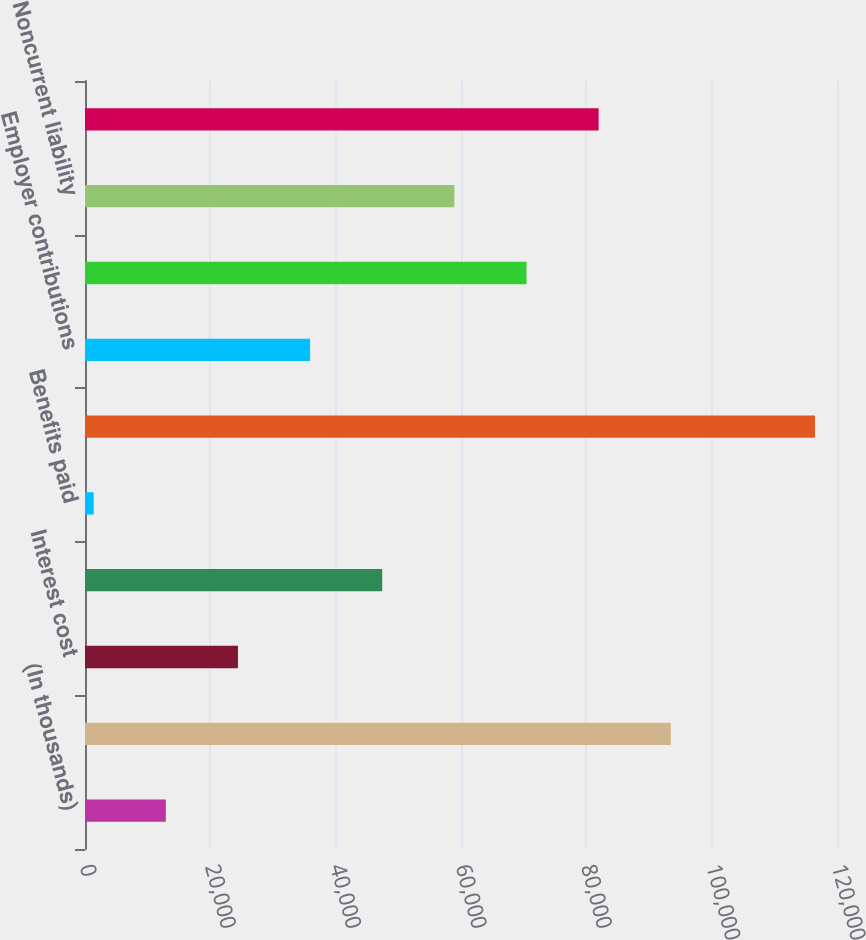Convert chart. <chart><loc_0><loc_0><loc_500><loc_500><bar_chart><fcel>(In thousands)<fcel>Obligation at beginning of<fcel>Interest cost<fcel>Actuarial loss (gain)<fcel>Benefits paid<fcel>Obligation at end of year<fcel>Employer contributions<fcel>Funded status recognized<fcel>Noncurrent liability<fcel>Net amount recognized<nl><fcel>12897.6<fcel>93471.8<fcel>24408.2<fcel>47429.4<fcel>1387<fcel>116493<fcel>35918.8<fcel>70450.6<fcel>58940<fcel>81961.2<nl></chart> 